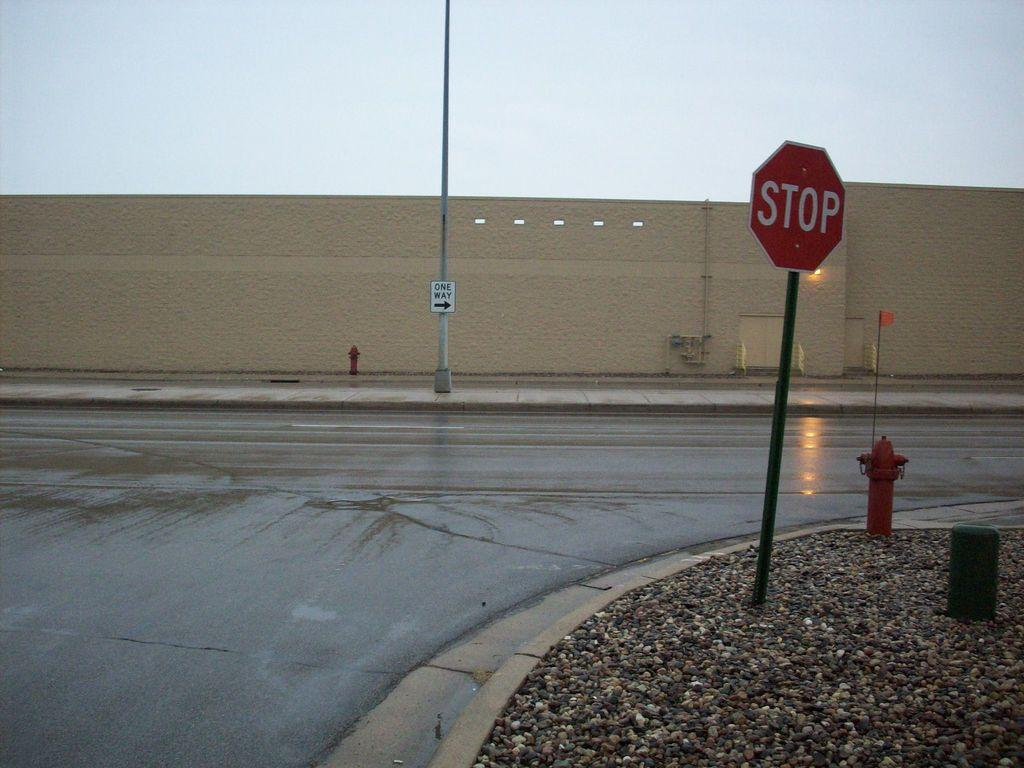<image>
Present a compact description of the photo's key features. A stop sign stands by the side of a wet road. 